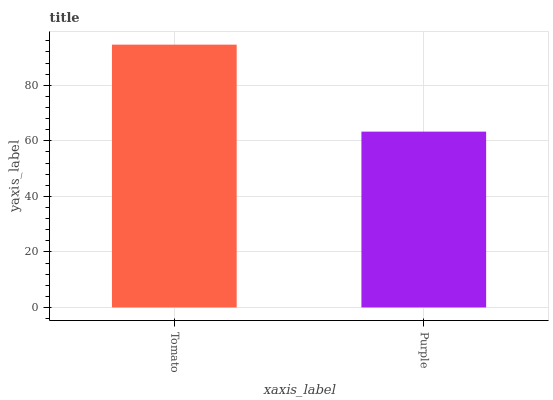Is Purple the maximum?
Answer yes or no. No. Is Tomato greater than Purple?
Answer yes or no. Yes. Is Purple less than Tomato?
Answer yes or no. Yes. Is Purple greater than Tomato?
Answer yes or no. No. Is Tomato less than Purple?
Answer yes or no. No. Is Tomato the high median?
Answer yes or no. Yes. Is Purple the low median?
Answer yes or no. Yes. Is Purple the high median?
Answer yes or no. No. Is Tomato the low median?
Answer yes or no. No. 